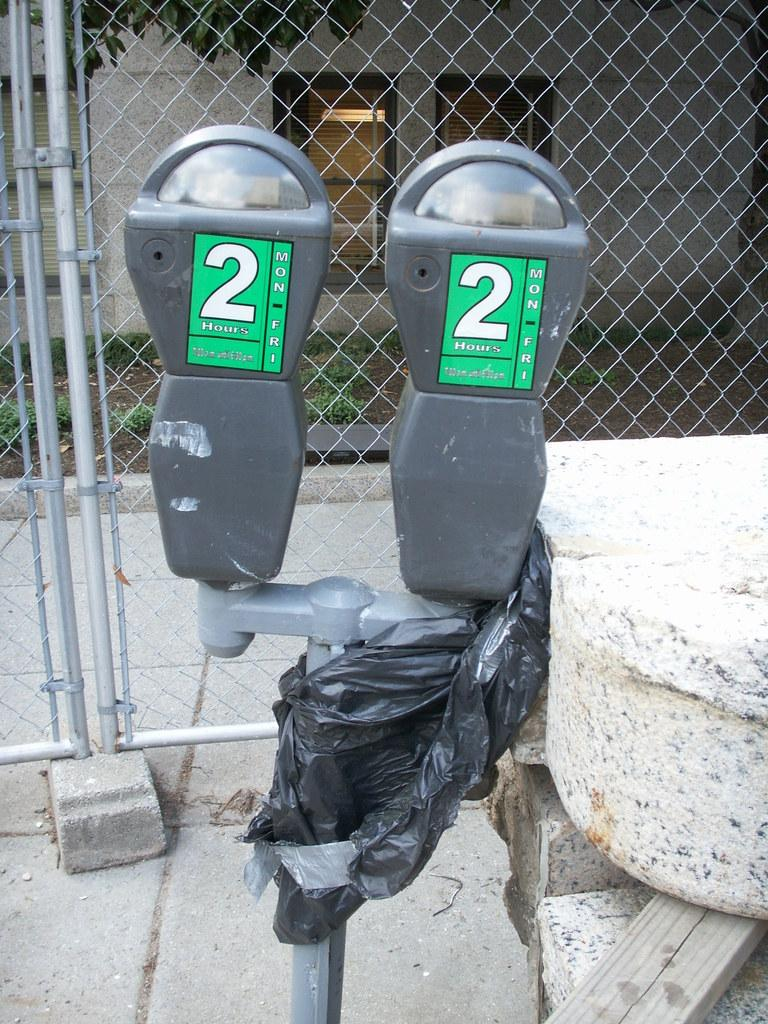What objects are located in the center of the image? There are parking meters in the center of the image. What type of natural feature can be seen on the right side of the image? There are rocks on the right side of the image. What can be seen in the background of the image? There is a mesh, a tree, and a building visible in the background of the image. What type of surprise can be seen on the left side of the image? There is no surprise present in the image; it features parking meters, rocks, and a background with a mesh, tree, and building. Can you tell me how many cats are visible in the image? There are no cats present in the image. 